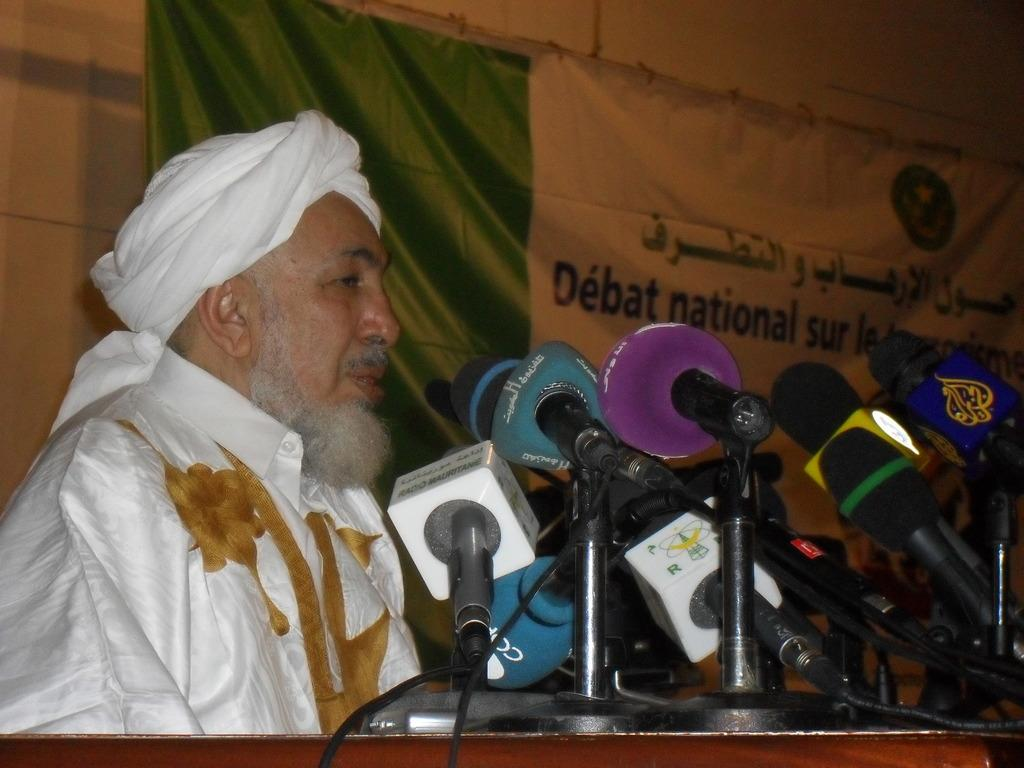Who is the main subject in the image? There is a man in the image. What is the man's proximity to in the image? The man is near a podium. What objects are on the podium? There are microphones on the podium. What can be seen in the background of the image? There is a banner and a wall in the background of the image. How many fingers does the man have on his left hand in the image? The image does not provide enough detail to determine the number of fingers on the man's left hand. 